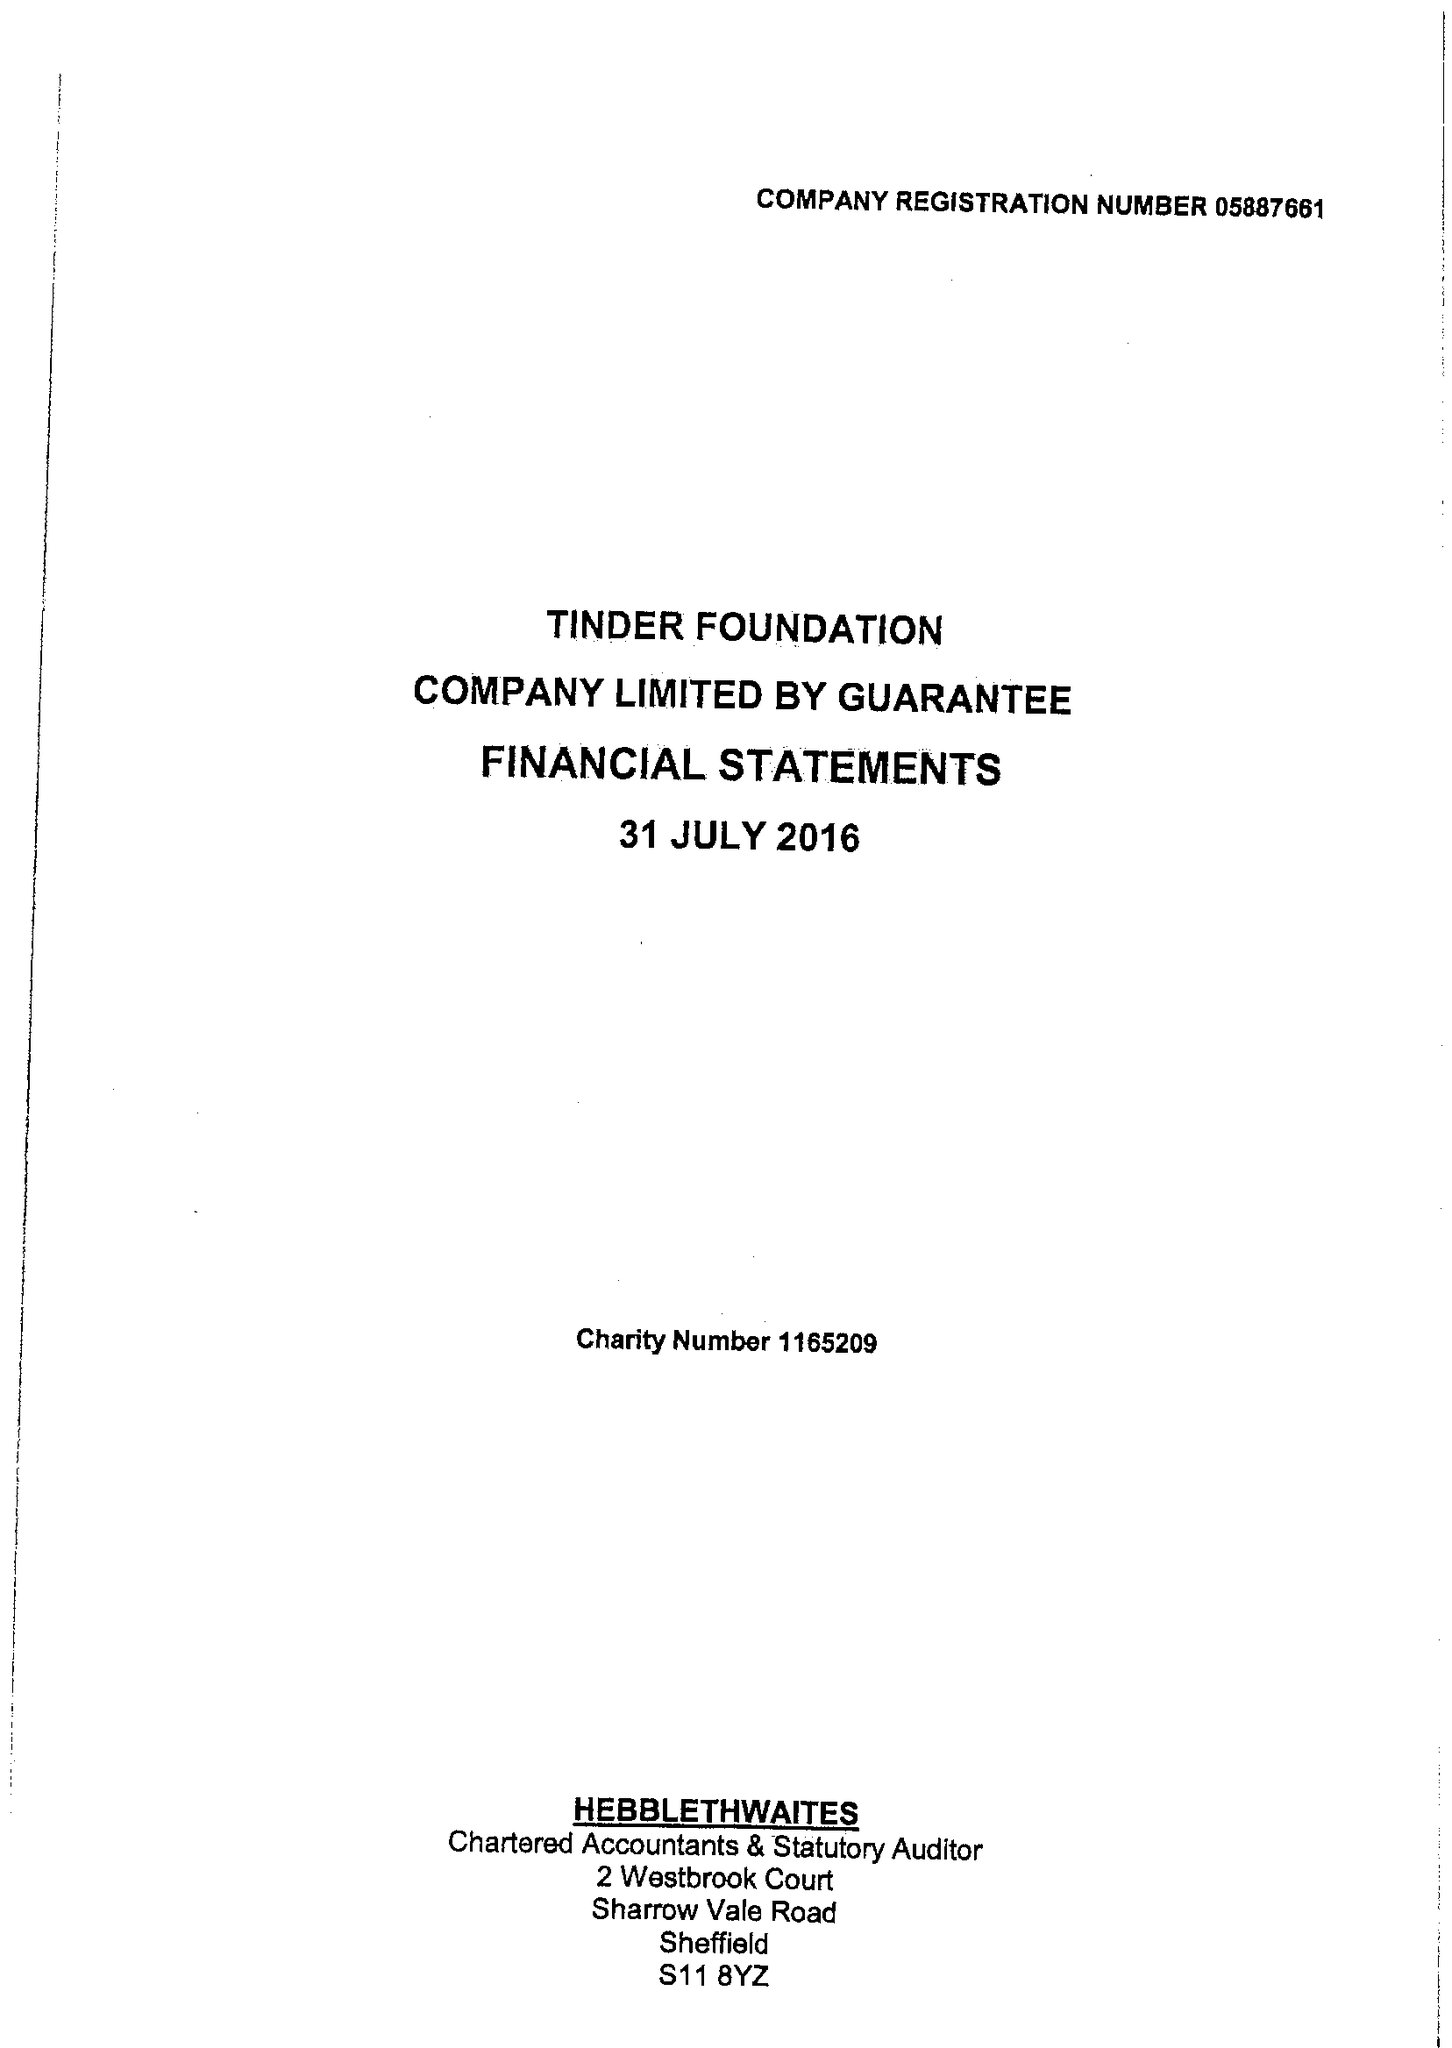What is the value for the report_date?
Answer the question using a single word or phrase. 2016-07-31 